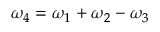Convert formula to latex. <formula><loc_0><loc_0><loc_500><loc_500>\omega _ { 4 } = \omega _ { 1 } + \omega _ { 2 } - \omega _ { 3 }</formula> 